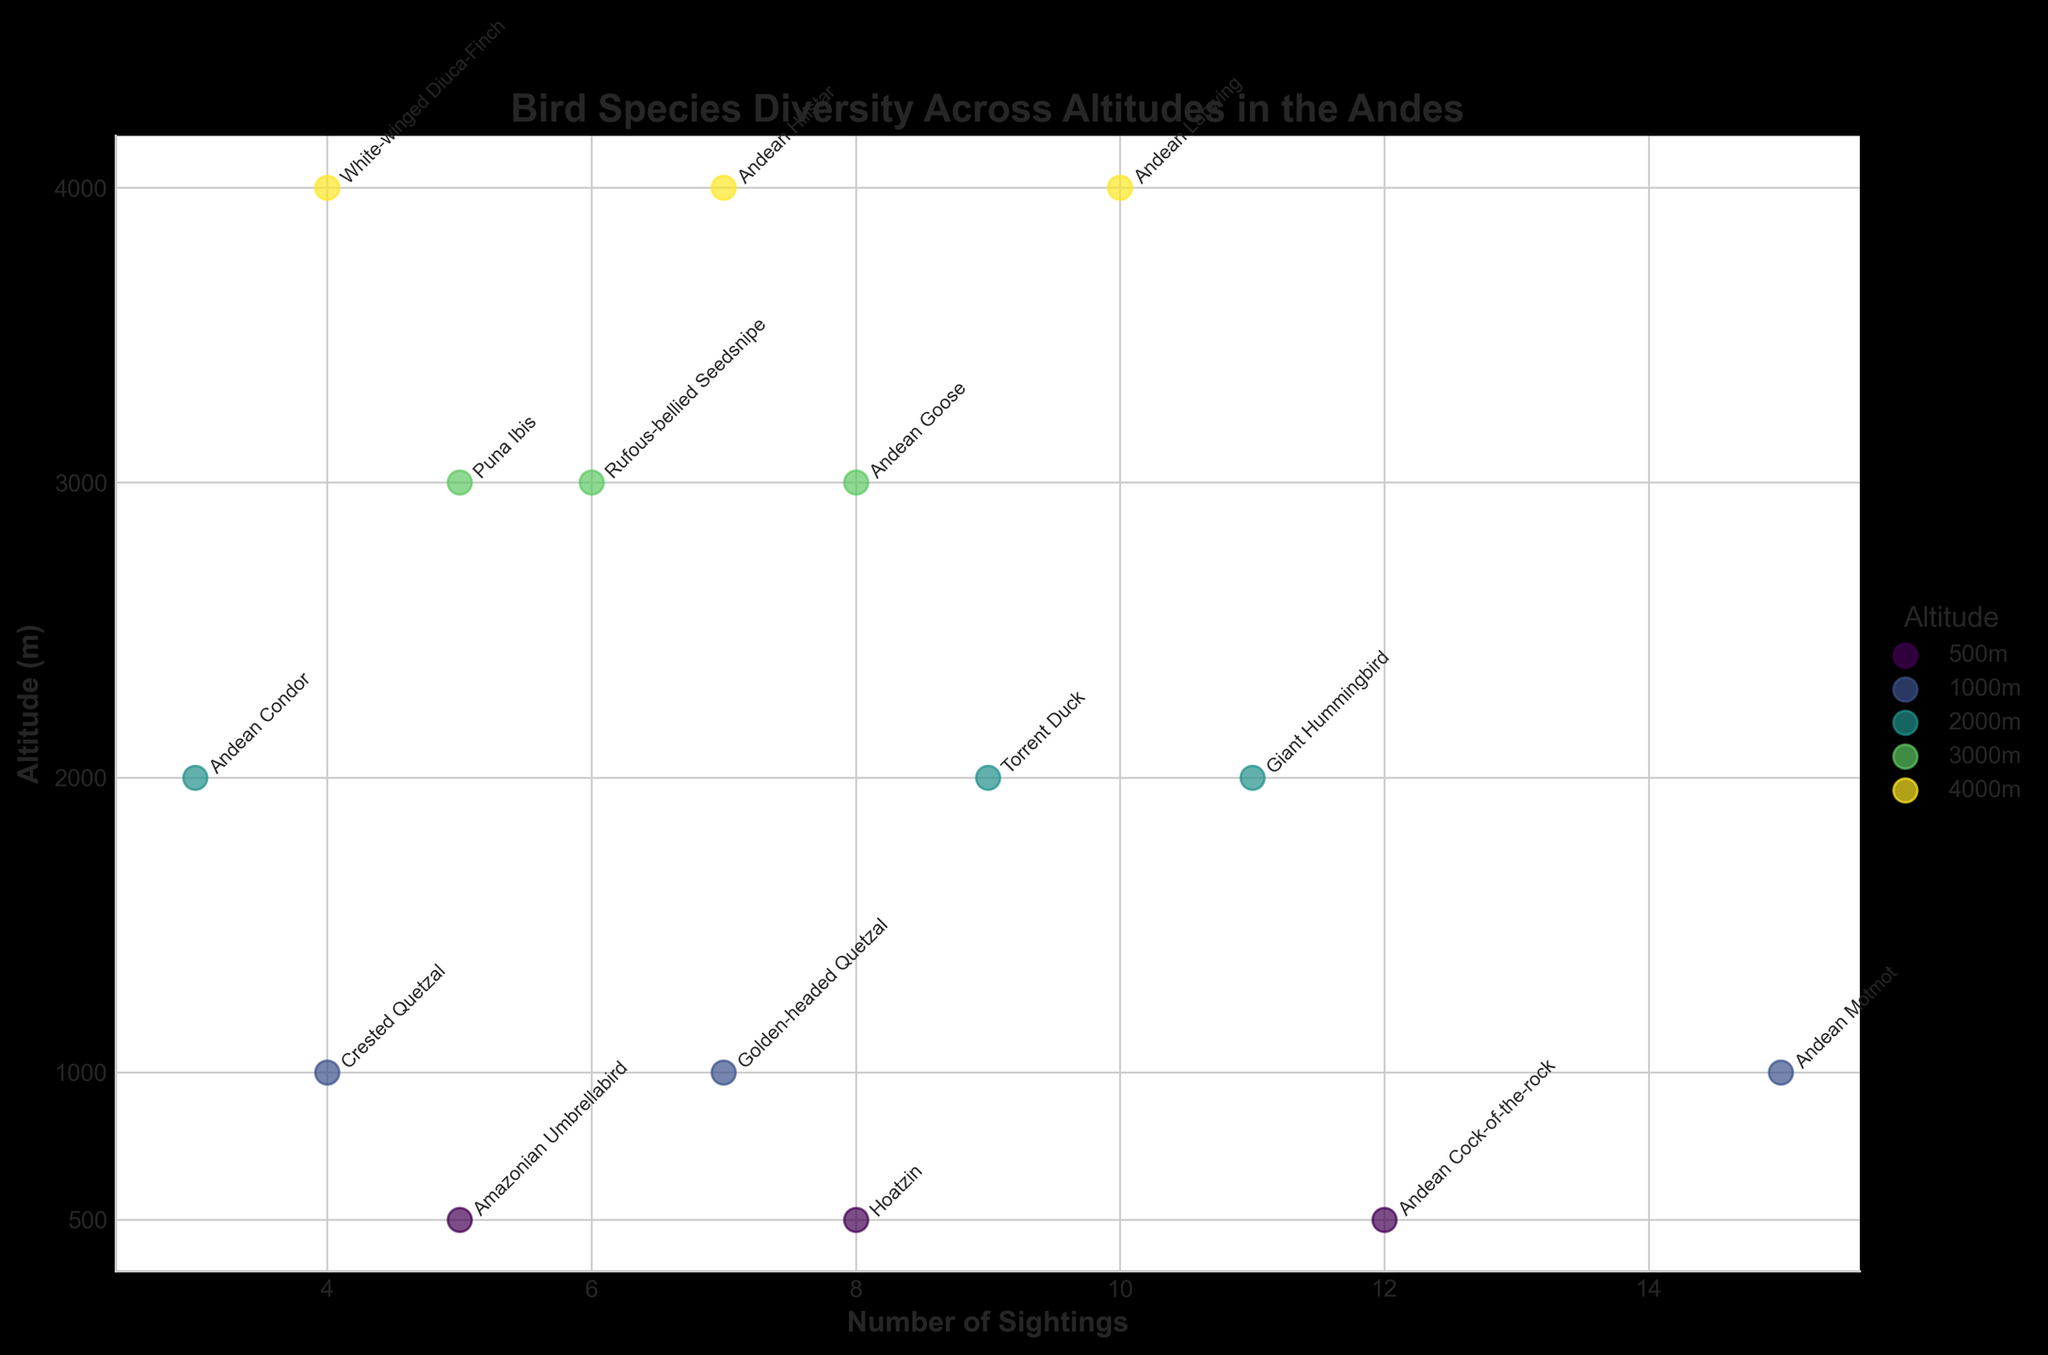What's the title of the plot? The title is usually located at the top of the plot. In this case, it states the main focus of the figure related to the bird species diversity.
Answer: Bird Species Diversity Across Altitudes in the Andes What does the x-axis represent? The x-axis labels indicate what values are represented horizontally in the plot. Here, it shows the quantity of individual birds counted.
Answer: Number of Sightings What altitudes are represented in the plot? The y-axis has labels that indicate specific altitudes. By looking at the ticks on the y-axis, we can see the distinct altitude levels.
Answer: 500m, 1000m, 2000m, 3000m, 4000m Which bird species has the most sightings at 500 meters? Focusing on the 500-meter altitude line, we can see the scatter points annotated with the bird species names and their respective number of sightings.
Answer: Andean Cock-of-the-rock How many species are represented at the 2000-meter altitude? We need to identify the number of different annotated points directly lined up with the 2000-meter y-axis tick.
Answer: 3 species Compare the sightings of "Andean Goose" and "Giant Hummingbird". Which one has more sightings and by how much? Identifying the sightings for each species and calculating the difference can give us the answer. Andean Goose at 3000m has 8 sightings whereas Giant Hummingbird at 2000m has 11 sightings. The difference is 11 - 8.
Answer: Giant Hummingbird by 3 Which bird species at 4000 meters have more than 7 sightings? By checking the points and their annotations along the 4000-meter altitude line, we look for any species with sightings greater than 7.
Answer: Andean Lapwing What's the most sighted bird species overall? By comparing the number of sightings for all species annotations across all altitudes, we find the one with the highest count.
Answer: Andean Motmot 